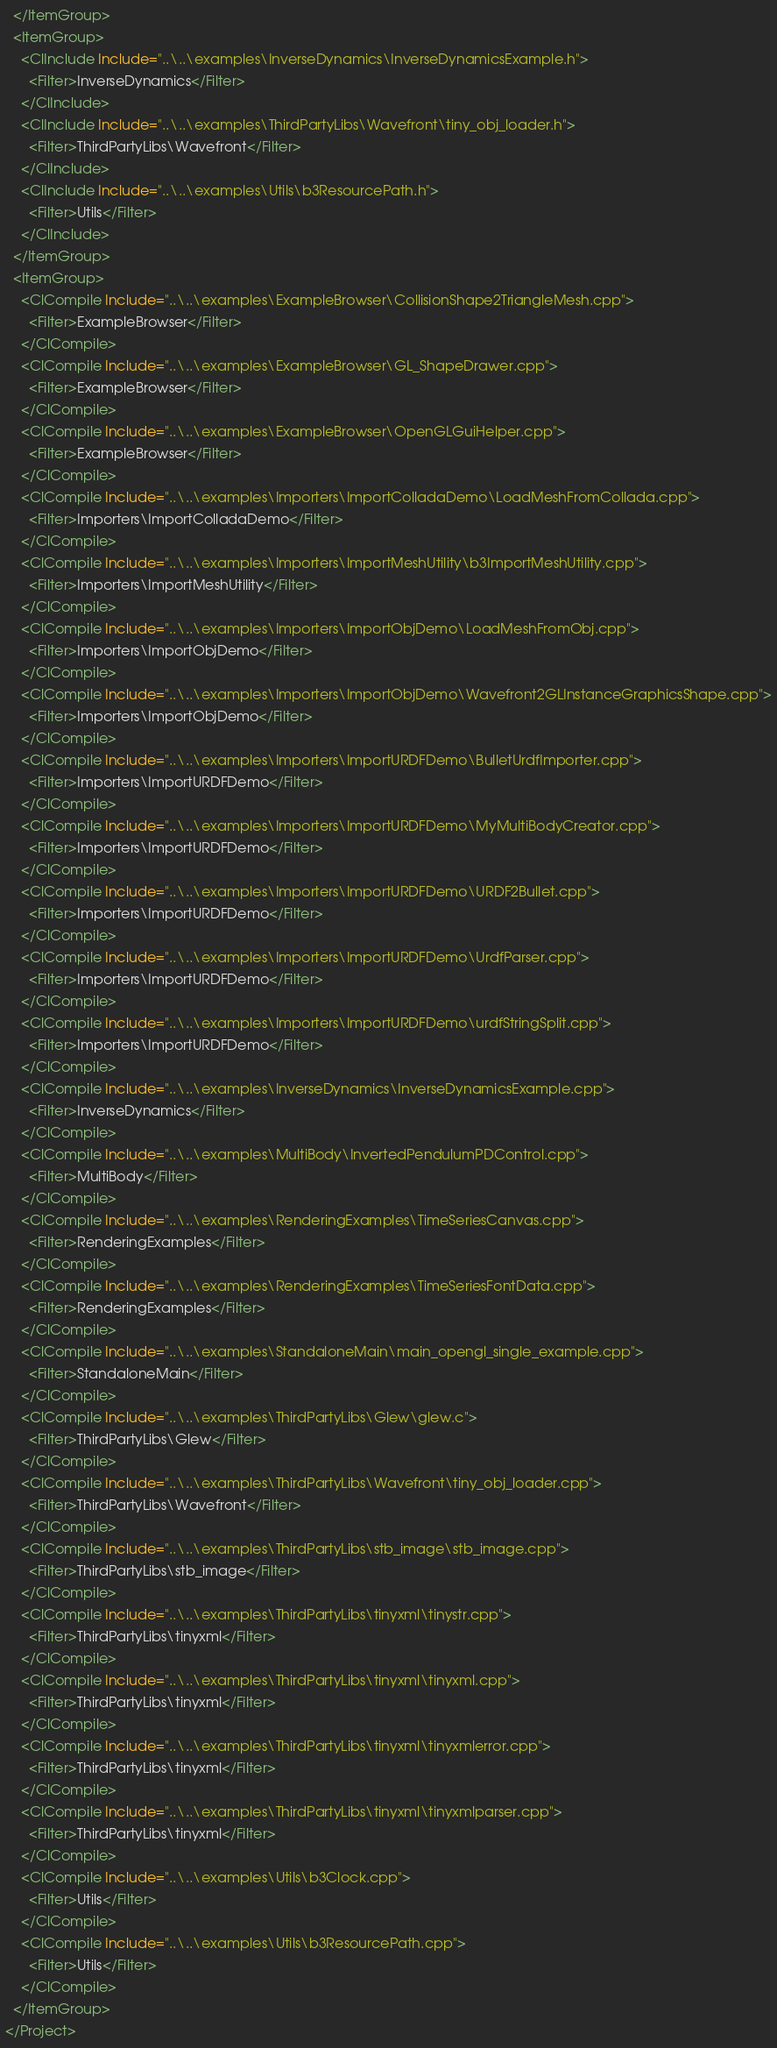<code> <loc_0><loc_0><loc_500><loc_500><_XML_>  </ItemGroup>
  <ItemGroup>
    <ClInclude Include="..\..\examples\InverseDynamics\InverseDynamicsExample.h">
      <Filter>InverseDynamics</Filter>
    </ClInclude>
    <ClInclude Include="..\..\examples\ThirdPartyLibs\Wavefront\tiny_obj_loader.h">
      <Filter>ThirdPartyLibs\Wavefront</Filter>
    </ClInclude>
    <ClInclude Include="..\..\examples\Utils\b3ResourcePath.h">
      <Filter>Utils</Filter>
    </ClInclude>
  </ItemGroup>
  <ItemGroup>
    <ClCompile Include="..\..\examples\ExampleBrowser\CollisionShape2TriangleMesh.cpp">
      <Filter>ExampleBrowser</Filter>
    </ClCompile>
    <ClCompile Include="..\..\examples\ExampleBrowser\GL_ShapeDrawer.cpp">
      <Filter>ExampleBrowser</Filter>
    </ClCompile>
    <ClCompile Include="..\..\examples\ExampleBrowser\OpenGLGuiHelper.cpp">
      <Filter>ExampleBrowser</Filter>
    </ClCompile>
    <ClCompile Include="..\..\examples\Importers\ImportColladaDemo\LoadMeshFromCollada.cpp">
      <Filter>Importers\ImportColladaDemo</Filter>
    </ClCompile>
    <ClCompile Include="..\..\examples\Importers\ImportMeshUtility\b3ImportMeshUtility.cpp">
      <Filter>Importers\ImportMeshUtility</Filter>
    </ClCompile>
    <ClCompile Include="..\..\examples\Importers\ImportObjDemo\LoadMeshFromObj.cpp">
      <Filter>Importers\ImportObjDemo</Filter>
    </ClCompile>
    <ClCompile Include="..\..\examples\Importers\ImportObjDemo\Wavefront2GLInstanceGraphicsShape.cpp">
      <Filter>Importers\ImportObjDemo</Filter>
    </ClCompile>
    <ClCompile Include="..\..\examples\Importers\ImportURDFDemo\BulletUrdfImporter.cpp">
      <Filter>Importers\ImportURDFDemo</Filter>
    </ClCompile>
    <ClCompile Include="..\..\examples\Importers\ImportURDFDemo\MyMultiBodyCreator.cpp">
      <Filter>Importers\ImportURDFDemo</Filter>
    </ClCompile>
    <ClCompile Include="..\..\examples\Importers\ImportURDFDemo\URDF2Bullet.cpp">
      <Filter>Importers\ImportURDFDemo</Filter>
    </ClCompile>
    <ClCompile Include="..\..\examples\Importers\ImportURDFDemo\UrdfParser.cpp">
      <Filter>Importers\ImportURDFDemo</Filter>
    </ClCompile>
    <ClCompile Include="..\..\examples\Importers\ImportURDFDemo\urdfStringSplit.cpp">
      <Filter>Importers\ImportURDFDemo</Filter>
    </ClCompile>
    <ClCompile Include="..\..\examples\InverseDynamics\InverseDynamicsExample.cpp">
      <Filter>InverseDynamics</Filter>
    </ClCompile>
    <ClCompile Include="..\..\examples\MultiBody\InvertedPendulumPDControl.cpp">
      <Filter>MultiBody</Filter>
    </ClCompile>
    <ClCompile Include="..\..\examples\RenderingExamples\TimeSeriesCanvas.cpp">
      <Filter>RenderingExamples</Filter>
    </ClCompile>
    <ClCompile Include="..\..\examples\RenderingExamples\TimeSeriesFontData.cpp">
      <Filter>RenderingExamples</Filter>
    </ClCompile>
    <ClCompile Include="..\..\examples\StandaloneMain\main_opengl_single_example.cpp">
      <Filter>StandaloneMain</Filter>
    </ClCompile>
    <ClCompile Include="..\..\examples\ThirdPartyLibs\Glew\glew.c">
      <Filter>ThirdPartyLibs\Glew</Filter>
    </ClCompile>
    <ClCompile Include="..\..\examples\ThirdPartyLibs\Wavefront\tiny_obj_loader.cpp">
      <Filter>ThirdPartyLibs\Wavefront</Filter>
    </ClCompile>
    <ClCompile Include="..\..\examples\ThirdPartyLibs\stb_image\stb_image.cpp">
      <Filter>ThirdPartyLibs\stb_image</Filter>
    </ClCompile>
    <ClCompile Include="..\..\examples\ThirdPartyLibs\tinyxml\tinystr.cpp">
      <Filter>ThirdPartyLibs\tinyxml</Filter>
    </ClCompile>
    <ClCompile Include="..\..\examples\ThirdPartyLibs\tinyxml\tinyxml.cpp">
      <Filter>ThirdPartyLibs\tinyxml</Filter>
    </ClCompile>
    <ClCompile Include="..\..\examples\ThirdPartyLibs\tinyxml\tinyxmlerror.cpp">
      <Filter>ThirdPartyLibs\tinyxml</Filter>
    </ClCompile>
    <ClCompile Include="..\..\examples\ThirdPartyLibs\tinyxml\tinyxmlparser.cpp">
      <Filter>ThirdPartyLibs\tinyxml</Filter>
    </ClCompile>
    <ClCompile Include="..\..\examples\Utils\b3Clock.cpp">
      <Filter>Utils</Filter>
    </ClCompile>
    <ClCompile Include="..\..\examples\Utils\b3ResourcePath.cpp">
      <Filter>Utils</Filter>
    </ClCompile>
  </ItemGroup>
</Project></code> 